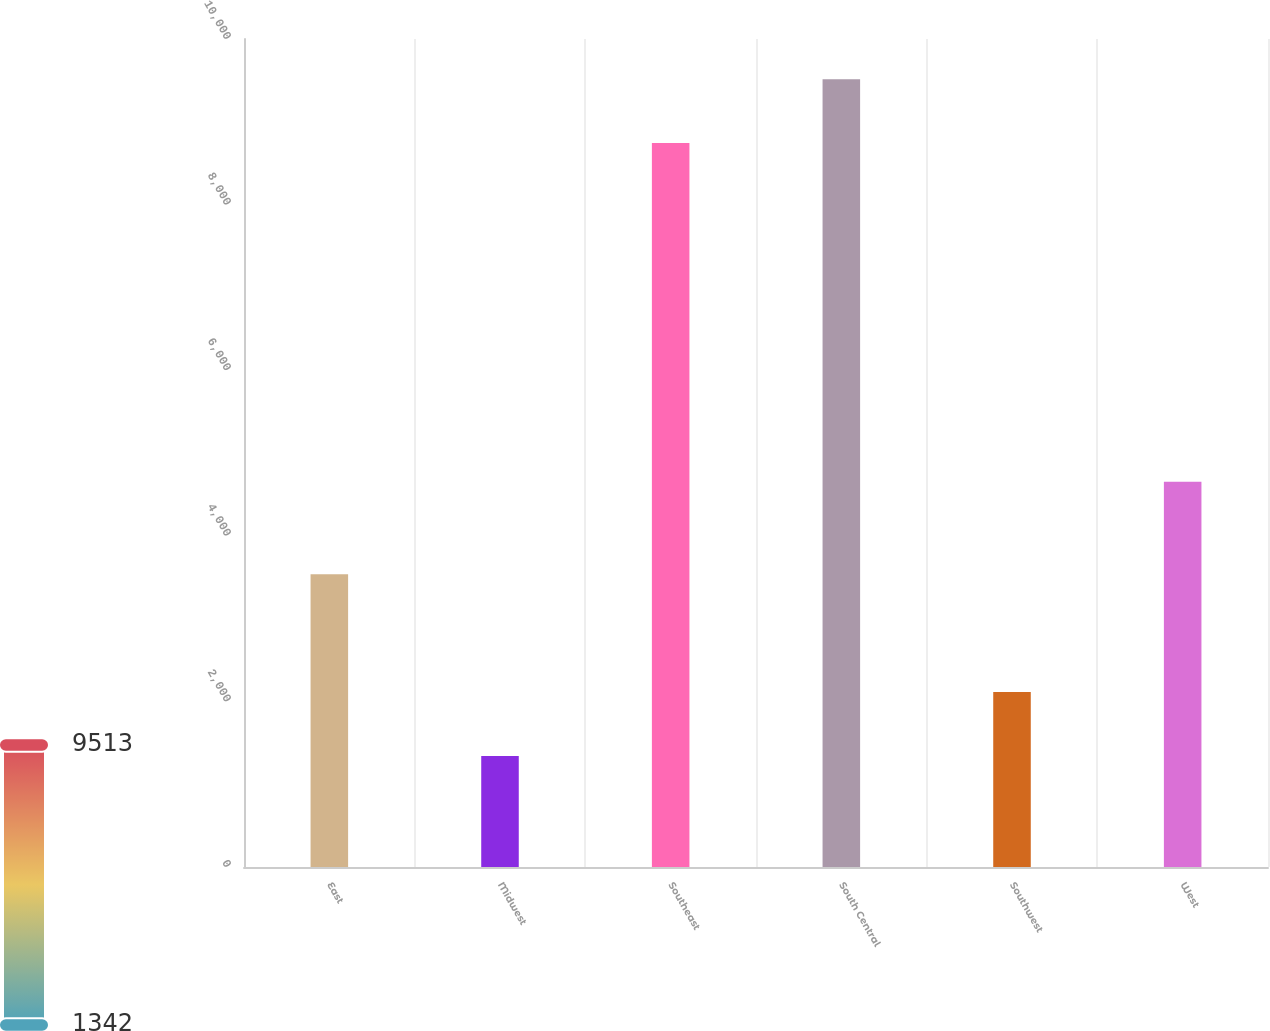<chart> <loc_0><loc_0><loc_500><loc_500><bar_chart><fcel>East<fcel>Midwest<fcel>Southeast<fcel>South Central<fcel>Southwest<fcel>West<nl><fcel>3537<fcel>1342<fcel>8743<fcel>9513.4<fcel>2112.4<fcel>4654<nl></chart> 